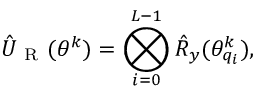Convert formula to latex. <formula><loc_0><loc_0><loc_500><loc_500>\hat { U } _ { R } ( \theta ^ { k } ) = \bigotimes _ { i = 0 } ^ { L - 1 } \hat { R } _ { y } ( \theta _ { q _ { i } } ^ { k } ) ,</formula> 